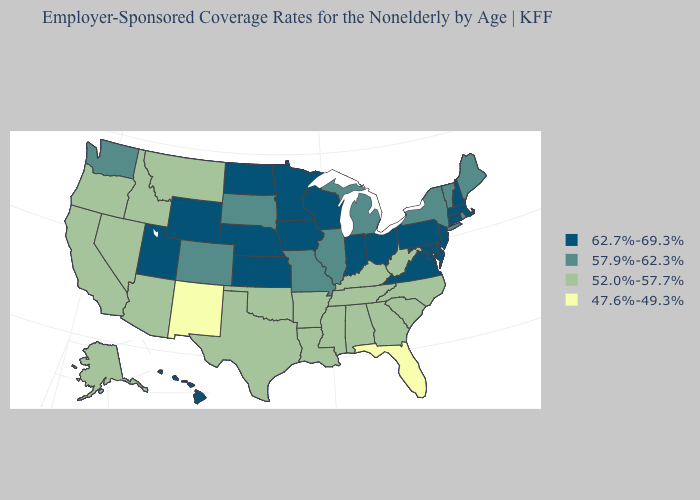What is the value of North Carolina?
Answer briefly. 52.0%-57.7%. Which states hav the highest value in the MidWest?
Keep it brief. Indiana, Iowa, Kansas, Minnesota, Nebraska, North Dakota, Ohio, Wisconsin. Which states hav the highest value in the South?
Concise answer only. Delaware, Maryland, Virginia. Which states have the lowest value in the South?
Concise answer only. Florida. Does Louisiana have the lowest value in the USA?
Be succinct. No. What is the value of Washington?
Give a very brief answer. 57.9%-62.3%. What is the value of Tennessee?
Give a very brief answer. 52.0%-57.7%. How many symbols are there in the legend?
Quick response, please. 4. Does Vermont have the highest value in the Northeast?
Be succinct. No. Which states have the highest value in the USA?
Keep it brief. Connecticut, Delaware, Hawaii, Indiana, Iowa, Kansas, Maryland, Massachusetts, Minnesota, Nebraska, New Hampshire, New Jersey, North Dakota, Ohio, Pennsylvania, Utah, Virginia, Wisconsin, Wyoming. What is the value of Rhode Island?
Concise answer only. 57.9%-62.3%. Does Mississippi have the lowest value in the USA?
Concise answer only. No. What is the lowest value in states that border Maine?
Be succinct. 62.7%-69.3%. 